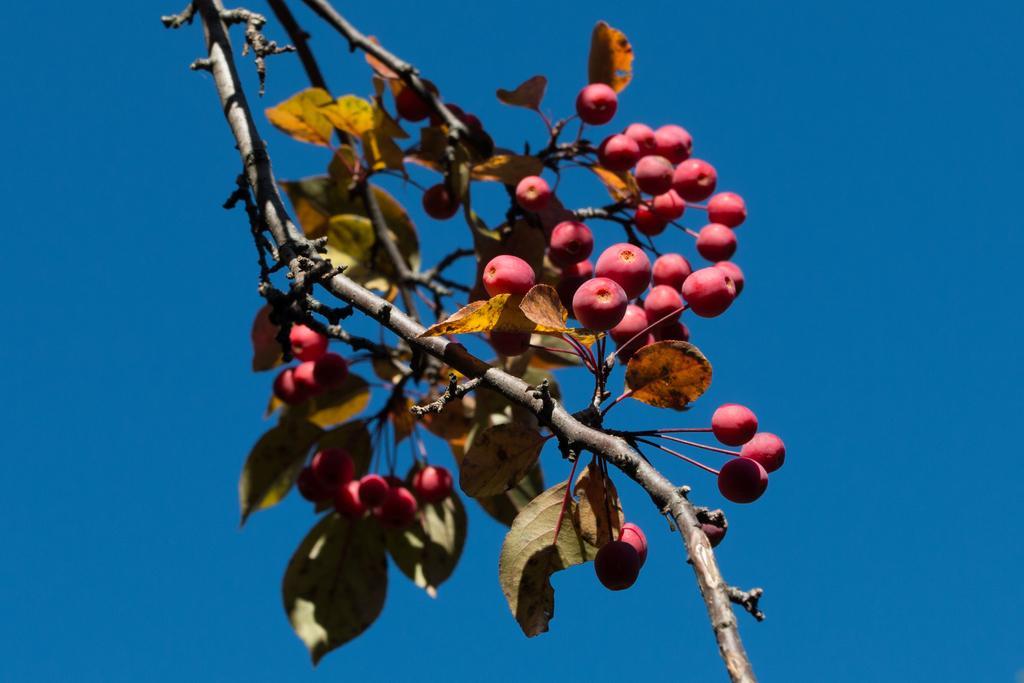How would you summarize this image in a sentence or two? Here we can see fruits to a tree and this is a sky. 